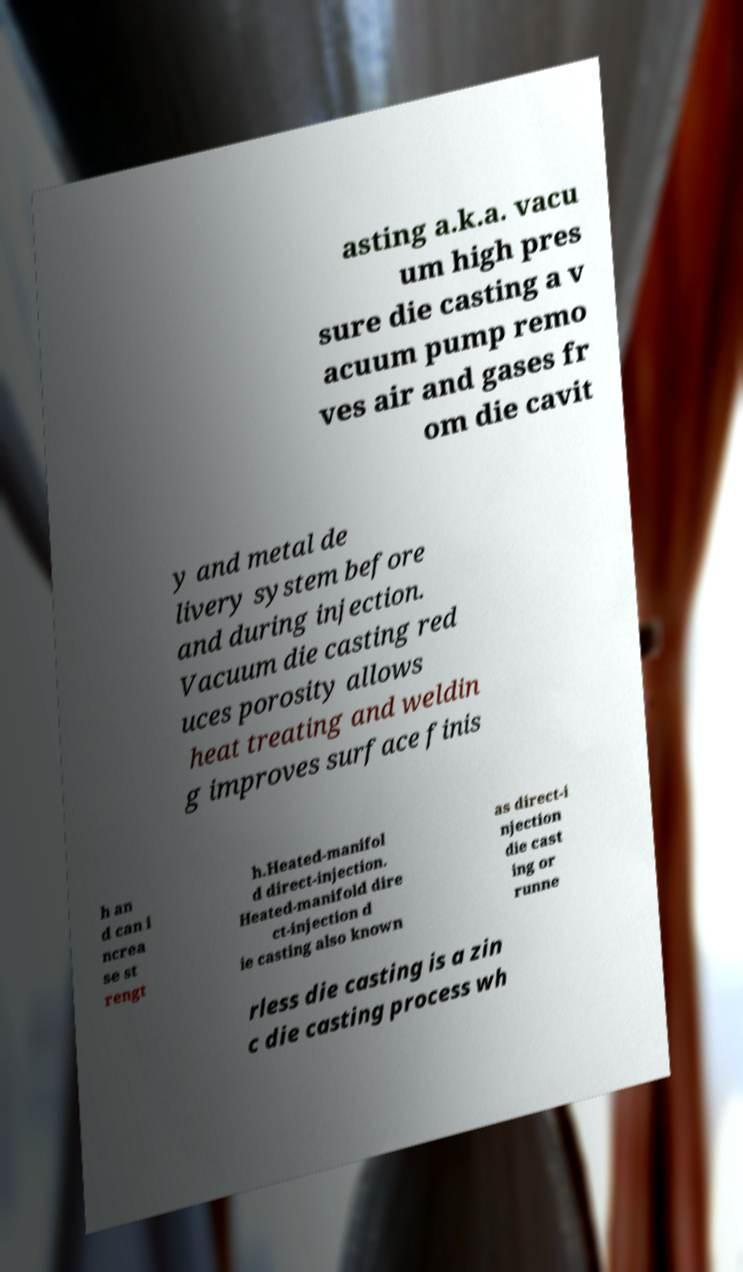For documentation purposes, I need the text within this image transcribed. Could you provide that? asting a.k.a. vacu um high pres sure die casting a v acuum pump remo ves air and gases fr om die cavit y and metal de livery system before and during injection. Vacuum die casting red uces porosity allows heat treating and weldin g improves surface finis h an d can i ncrea se st rengt h.Heated-manifol d direct-injection. Heated-manifold dire ct-injection d ie casting also known as direct-i njection die cast ing or runne rless die casting is a zin c die casting process wh 